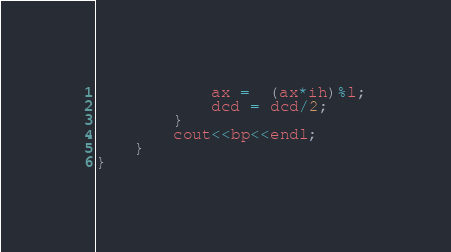<code> <loc_0><loc_0><loc_500><loc_500><_C++_>            ax =  (ax*ih)%l;
            dcd = dcd/2;
        }
        cout<<bp<<endl;
    }
}</code> 